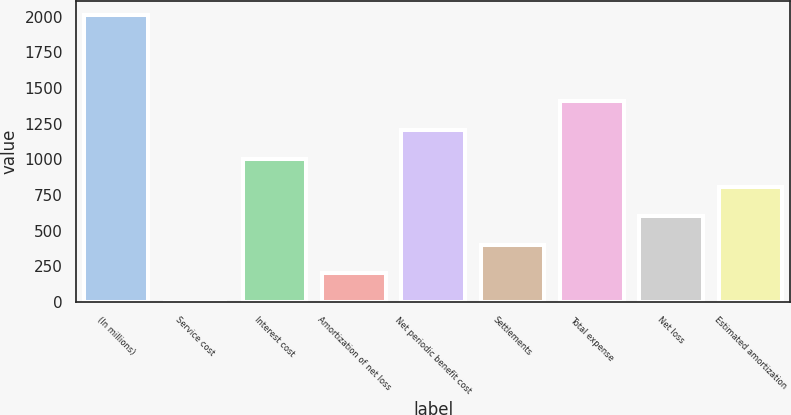Convert chart. <chart><loc_0><loc_0><loc_500><loc_500><bar_chart><fcel>(In millions)<fcel>Service cost<fcel>Interest cost<fcel>Amortization of net loss<fcel>Net periodic benefit cost<fcel>Settlements<fcel>Total expense<fcel>Net loss<fcel>Estimated amortization<nl><fcel>2009<fcel>2<fcel>1005.5<fcel>202.7<fcel>1206.2<fcel>403.4<fcel>1406.9<fcel>604.1<fcel>804.8<nl></chart> 